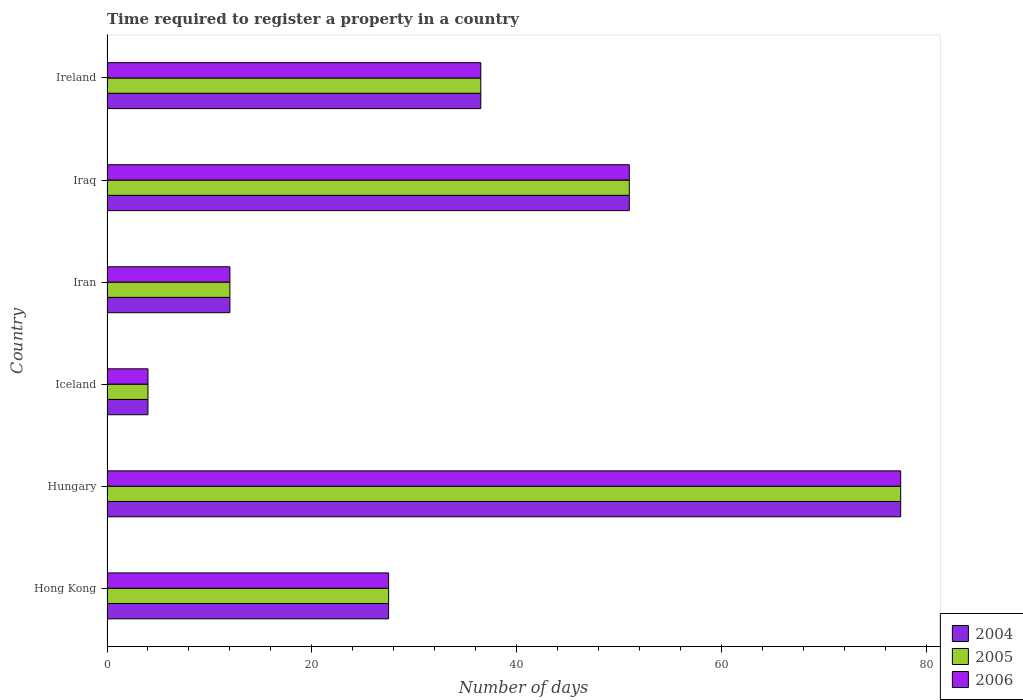How many groups of bars are there?
Offer a very short reply. 6. Are the number of bars on each tick of the Y-axis equal?
Ensure brevity in your answer.  Yes. How many bars are there on the 5th tick from the bottom?
Offer a very short reply. 3. What is the label of the 2nd group of bars from the top?
Offer a very short reply. Iraq. What is the number of days required to register a property in 2006 in Hungary?
Your answer should be very brief. 77.5. Across all countries, what is the maximum number of days required to register a property in 2005?
Provide a succinct answer. 77.5. Across all countries, what is the minimum number of days required to register a property in 2006?
Your answer should be compact. 4. In which country was the number of days required to register a property in 2006 maximum?
Offer a very short reply. Hungary. What is the total number of days required to register a property in 2006 in the graph?
Give a very brief answer. 208.5. What is the difference between the number of days required to register a property in 2004 in Hungary and that in Iran?
Offer a very short reply. 65.5. What is the difference between the number of days required to register a property in 2004 in Iraq and the number of days required to register a property in 2005 in Hong Kong?
Offer a terse response. 23.5. What is the average number of days required to register a property in 2005 per country?
Offer a very short reply. 34.75. What is the difference between the number of days required to register a property in 2004 and number of days required to register a property in 2005 in Hong Kong?
Offer a very short reply. 0. In how many countries, is the number of days required to register a property in 2004 greater than 12 days?
Your answer should be very brief. 4. What is the ratio of the number of days required to register a property in 2006 in Iran to that in Ireland?
Offer a very short reply. 0.33. Is the number of days required to register a property in 2005 in Hungary less than that in Iran?
Your response must be concise. No. Is the difference between the number of days required to register a property in 2004 in Iraq and Ireland greater than the difference between the number of days required to register a property in 2005 in Iraq and Ireland?
Ensure brevity in your answer.  No. What is the difference between the highest and the lowest number of days required to register a property in 2005?
Offer a very short reply. 73.5. Is the sum of the number of days required to register a property in 2004 in Iceland and Iran greater than the maximum number of days required to register a property in 2005 across all countries?
Offer a terse response. No. How many bars are there?
Your response must be concise. 18. Are all the bars in the graph horizontal?
Offer a terse response. Yes. What is the difference between two consecutive major ticks on the X-axis?
Keep it short and to the point. 20. Does the graph contain any zero values?
Offer a very short reply. No. Where does the legend appear in the graph?
Provide a succinct answer. Bottom right. How many legend labels are there?
Your answer should be very brief. 3. What is the title of the graph?
Your response must be concise. Time required to register a property in a country. What is the label or title of the X-axis?
Your answer should be very brief. Number of days. What is the Number of days in 2004 in Hong Kong?
Provide a short and direct response. 27.5. What is the Number of days in 2004 in Hungary?
Keep it short and to the point. 77.5. What is the Number of days in 2005 in Hungary?
Give a very brief answer. 77.5. What is the Number of days of 2006 in Hungary?
Keep it short and to the point. 77.5. What is the Number of days in 2006 in Iceland?
Make the answer very short. 4. What is the Number of days of 2004 in Iran?
Keep it short and to the point. 12. What is the Number of days of 2005 in Iran?
Offer a very short reply. 12. What is the Number of days of 2004 in Iraq?
Give a very brief answer. 51. What is the Number of days of 2005 in Iraq?
Provide a short and direct response. 51. What is the Number of days in 2004 in Ireland?
Make the answer very short. 36.5. What is the Number of days of 2005 in Ireland?
Your answer should be very brief. 36.5. What is the Number of days in 2006 in Ireland?
Offer a terse response. 36.5. Across all countries, what is the maximum Number of days of 2004?
Give a very brief answer. 77.5. Across all countries, what is the maximum Number of days of 2005?
Provide a short and direct response. 77.5. Across all countries, what is the maximum Number of days of 2006?
Offer a terse response. 77.5. Across all countries, what is the minimum Number of days in 2004?
Your answer should be very brief. 4. What is the total Number of days of 2004 in the graph?
Your answer should be very brief. 208.5. What is the total Number of days of 2005 in the graph?
Your answer should be very brief. 208.5. What is the total Number of days in 2006 in the graph?
Your answer should be compact. 208.5. What is the difference between the Number of days in 2006 in Hong Kong and that in Hungary?
Your answer should be very brief. -50. What is the difference between the Number of days in 2004 in Hong Kong and that in Iceland?
Your answer should be compact. 23.5. What is the difference between the Number of days in 2005 in Hong Kong and that in Iceland?
Provide a short and direct response. 23.5. What is the difference between the Number of days in 2006 in Hong Kong and that in Iceland?
Provide a short and direct response. 23.5. What is the difference between the Number of days in 2006 in Hong Kong and that in Iran?
Offer a terse response. 15.5. What is the difference between the Number of days of 2004 in Hong Kong and that in Iraq?
Provide a short and direct response. -23.5. What is the difference between the Number of days in 2005 in Hong Kong and that in Iraq?
Offer a very short reply. -23.5. What is the difference between the Number of days in 2006 in Hong Kong and that in Iraq?
Make the answer very short. -23.5. What is the difference between the Number of days of 2004 in Hong Kong and that in Ireland?
Give a very brief answer. -9. What is the difference between the Number of days of 2005 in Hong Kong and that in Ireland?
Keep it short and to the point. -9. What is the difference between the Number of days in 2004 in Hungary and that in Iceland?
Ensure brevity in your answer.  73.5. What is the difference between the Number of days in 2005 in Hungary and that in Iceland?
Your answer should be very brief. 73.5. What is the difference between the Number of days of 2006 in Hungary and that in Iceland?
Provide a succinct answer. 73.5. What is the difference between the Number of days of 2004 in Hungary and that in Iran?
Your answer should be compact. 65.5. What is the difference between the Number of days in 2005 in Hungary and that in Iran?
Make the answer very short. 65.5. What is the difference between the Number of days of 2006 in Hungary and that in Iran?
Your answer should be very brief. 65.5. What is the difference between the Number of days of 2004 in Hungary and that in Ireland?
Make the answer very short. 41. What is the difference between the Number of days of 2005 in Hungary and that in Ireland?
Offer a terse response. 41. What is the difference between the Number of days in 2004 in Iceland and that in Iran?
Make the answer very short. -8. What is the difference between the Number of days in 2005 in Iceland and that in Iran?
Provide a succinct answer. -8. What is the difference between the Number of days of 2006 in Iceland and that in Iran?
Provide a succinct answer. -8. What is the difference between the Number of days in 2004 in Iceland and that in Iraq?
Provide a short and direct response. -47. What is the difference between the Number of days of 2005 in Iceland and that in Iraq?
Ensure brevity in your answer.  -47. What is the difference between the Number of days of 2006 in Iceland and that in Iraq?
Your answer should be very brief. -47. What is the difference between the Number of days in 2004 in Iceland and that in Ireland?
Ensure brevity in your answer.  -32.5. What is the difference between the Number of days in 2005 in Iceland and that in Ireland?
Provide a short and direct response. -32.5. What is the difference between the Number of days in 2006 in Iceland and that in Ireland?
Make the answer very short. -32.5. What is the difference between the Number of days in 2004 in Iran and that in Iraq?
Offer a terse response. -39. What is the difference between the Number of days in 2005 in Iran and that in Iraq?
Give a very brief answer. -39. What is the difference between the Number of days of 2006 in Iran and that in Iraq?
Make the answer very short. -39. What is the difference between the Number of days of 2004 in Iran and that in Ireland?
Make the answer very short. -24.5. What is the difference between the Number of days of 2005 in Iran and that in Ireland?
Keep it short and to the point. -24.5. What is the difference between the Number of days in 2006 in Iran and that in Ireland?
Give a very brief answer. -24.5. What is the difference between the Number of days of 2006 in Iraq and that in Ireland?
Provide a short and direct response. 14.5. What is the difference between the Number of days of 2004 in Hong Kong and the Number of days of 2005 in Hungary?
Offer a terse response. -50. What is the difference between the Number of days of 2004 in Hong Kong and the Number of days of 2005 in Iceland?
Your response must be concise. 23.5. What is the difference between the Number of days in 2005 in Hong Kong and the Number of days in 2006 in Iceland?
Provide a succinct answer. 23.5. What is the difference between the Number of days in 2004 in Hong Kong and the Number of days in 2005 in Iran?
Offer a very short reply. 15.5. What is the difference between the Number of days of 2004 in Hong Kong and the Number of days of 2005 in Iraq?
Your response must be concise. -23.5. What is the difference between the Number of days in 2004 in Hong Kong and the Number of days in 2006 in Iraq?
Provide a short and direct response. -23.5. What is the difference between the Number of days in 2005 in Hong Kong and the Number of days in 2006 in Iraq?
Your response must be concise. -23.5. What is the difference between the Number of days of 2005 in Hong Kong and the Number of days of 2006 in Ireland?
Provide a short and direct response. -9. What is the difference between the Number of days in 2004 in Hungary and the Number of days in 2005 in Iceland?
Your response must be concise. 73.5. What is the difference between the Number of days in 2004 in Hungary and the Number of days in 2006 in Iceland?
Your answer should be very brief. 73.5. What is the difference between the Number of days of 2005 in Hungary and the Number of days of 2006 in Iceland?
Ensure brevity in your answer.  73.5. What is the difference between the Number of days of 2004 in Hungary and the Number of days of 2005 in Iran?
Give a very brief answer. 65.5. What is the difference between the Number of days of 2004 in Hungary and the Number of days of 2006 in Iran?
Your response must be concise. 65.5. What is the difference between the Number of days in 2005 in Hungary and the Number of days in 2006 in Iran?
Offer a terse response. 65.5. What is the difference between the Number of days of 2004 in Hungary and the Number of days of 2005 in Iraq?
Keep it short and to the point. 26.5. What is the difference between the Number of days of 2005 in Hungary and the Number of days of 2006 in Iraq?
Provide a succinct answer. 26.5. What is the difference between the Number of days of 2005 in Hungary and the Number of days of 2006 in Ireland?
Give a very brief answer. 41. What is the difference between the Number of days of 2004 in Iceland and the Number of days of 2005 in Iran?
Ensure brevity in your answer.  -8. What is the difference between the Number of days in 2005 in Iceland and the Number of days in 2006 in Iran?
Keep it short and to the point. -8. What is the difference between the Number of days of 2004 in Iceland and the Number of days of 2005 in Iraq?
Offer a very short reply. -47. What is the difference between the Number of days in 2004 in Iceland and the Number of days in 2006 in Iraq?
Give a very brief answer. -47. What is the difference between the Number of days in 2005 in Iceland and the Number of days in 2006 in Iraq?
Ensure brevity in your answer.  -47. What is the difference between the Number of days of 2004 in Iceland and the Number of days of 2005 in Ireland?
Provide a succinct answer. -32.5. What is the difference between the Number of days of 2004 in Iceland and the Number of days of 2006 in Ireland?
Make the answer very short. -32.5. What is the difference between the Number of days of 2005 in Iceland and the Number of days of 2006 in Ireland?
Offer a terse response. -32.5. What is the difference between the Number of days of 2004 in Iran and the Number of days of 2005 in Iraq?
Give a very brief answer. -39. What is the difference between the Number of days in 2004 in Iran and the Number of days in 2006 in Iraq?
Provide a succinct answer. -39. What is the difference between the Number of days in 2005 in Iran and the Number of days in 2006 in Iraq?
Provide a short and direct response. -39. What is the difference between the Number of days in 2004 in Iran and the Number of days in 2005 in Ireland?
Your response must be concise. -24.5. What is the difference between the Number of days in 2004 in Iran and the Number of days in 2006 in Ireland?
Your answer should be very brief. -24.5. What is the difference between the Number of days of 2005 in Iran and the Number of days of 2006 in Ireland?
Give a very brief answer. -24.5. What is the difference between the Number of days in 2004 in Iraq and the Number of days in 2006 in Ireland?
Your answer should be compact. 14.5. What is the difference between the Number of days of 2005 in Iraq and the Number of days of 2006 in Ireland?
Your answer should be very brief. 14.5. What is the average Number of days in 2004 per country?
Offer a very short reply. 34.75. What is the average Number of days in 2005 per country?
Provide a short and direct response. 34.75. What is the average Number of days in 2006 per country?
Your response must be concise. 34.75. What is the difference between the Number of days in 2005 and Number of days in 2006 in Hong Kong?
Make the answer very short. 0. What is the difference between the Number of days of 2004 and Number of days of 2005 in Hungary?
Keep it short and to the point. 0. What is the difference between the Number of days of 2004 and Number of days of 2006 in Iceland?
Keep it short and to the point. 0. What is the difference between the Number of days in 2005 and Number of days in 2006 in Iraq?
Give a very brief answer. 0. What is the difference between the Number of days in 2004 and Number of days in 2006 in Ireland?
Your response must be concise. 0. What is the ratio of the Number of days of 2004 in Hong Kong to that in Hungary?
Your answer should be compact. 0.35. What is the ratio of the Number of days in 2005 in Hong Kong to that in Hungary?
Ensure brevity in your answer.  0.35. What is the ratio of the Number of days of 2006 in Hong Kong to that in Hungary?
Your response must be concise. 0.35. What is the ratio of the Number of days of 2004 in Hong Kong to that in Iceland?
Offer a very short reply. 6.88. What is the ratio of the Number of days in 2005 in Hong Kong to that in Iceland?
Offer a terse response. 6.88. What is the ratio of the Number of days of 2006 in Hong Kong to that in Iceland?
Give a very brief answer. 6.88. What is the ratio of the Number of days of 2004 in Hong Kong to that in Iran?
Your answer should be very brief. 2.29. What is the ratio of the Number of days in 2005 in Hong Kong to that in Iran?
Your answer should be very brief. 2.29. What is the ratio of the Number of days of 2006 in Hong Kong to that in Iran?
Make the answer very short. 2.29. What is the ratio of the Number of days of 2004 in Hong Kong to that in Iraq?
Offer a terse response. 0.54. What is the ratio of the Number of days in 2005 in Hong Kong to that in Iraq?
Provide a short and direct response. 0.54. What is the ratio of the Number of days of 2006 in Hong Kong to that in Iraq?
Offer a very short reply. 0.54. What is the ratio of the Number of days of 2004 in Hong Kong to that in Ireland?
Offer a terse response. 0.75. What is the ratio of the Number of days of 2005 in Hong Kong to that in Ireland?
Keep it short and to the point. 0.75. What is the ratio of the Number of days of 2006 in Hong Kong to that in Ireland?
Offer a very short reply. 0.75. What is the ratio of the Number of days of 2004 in Hungary to that in Iceland?
Your response must be concise. 19.38. What is the ratio of the Number of days of 2005 in Hungary to that in Iceland?
Your answer should be compact. 19.38. What is the ratio of the Number of days in 2006 in Hungary to that in Iceland?
Offer a terse response. 19.38. What is the ratio of the Number of days of 2004 in Hungary to that in Iran?
Provide a short and direct response. 6.46. What is the ratio of the Number of days in 2005 in Hungary to that in Iran?
Keep it short and to the point. 6.46. What is the ratio of the Number of days of 2006 in Hungary to that in Iran?
Your answer should be very brief. 6.46. What is the ratio of the Number of days in 2004 in Hungary to that in Iraq?
Your answer should be compact. 1.52. What is the ratio of the Number of days of 2005 in Hungary to that in Iraq?
Keep it short and to the point. 1.52. What is the ratio of the Number of days in 2006 in Hungary to that in Iraq?
Make the answer very short. 1.52. What is the ratio of the Number of days in 2004 in Hungary to that in Ireland?
Your response must be concise. 2.12. What is the ratio of the Number of days in 2005 in Hungary to that in Ireland?
Give a very brief answer. 2.12. What is the ratio of the Number of days in 2006 in Hungary to that in Ireland?
Make the answer very short. 2.12. What is the ratio of the Number of days in 2005 in Iceland to that in Iran?
Ensure brevity in your answer.  0.33. What is the ratio of the Number of days in 2006 in Iceland to that in Iran?
Ensure brevity in your answer.  0.33. What is the ratio of the Number of days in 2004 in Iceland to that in Iraq?
Your answer should be very brief. 0.08. What is the ratio of the Number of days of 2005 in Iceland to that in Iraq?
Give a very brief answer. 0.08. What is the ratio of the Number of days in 2006 in Iceland to that in Iraq?
Ensure brevity in your answer.  0.08. What is the ratio of the Number of days of 2004 in Iceland to that in Ireland?
Provide a short and direct response. 0.11. What is the ratio of the Number of days of 2005 in Iceland to that in Ireland?
Give a very brief answer. 0.11. What is the ratio of the Number of days in 2006 in Iceland to that in Ireland?
Your response must be concise. 0.11. What is the ratio of the Number of days in 2004 in Iran to that in Iraq?
Your answer should be very brief. 0.24. What is the ratio of the Number of days in 2005 in Iran to that in Iraq?
Your answer should be compact. 0.24. What is the ratio of the Number of days in 2006 in Iran to that in Iraq?
Offer a terse response. 0.24. What is the ratio of the Number of days of 2004 in Iran to that in Ireland?
Your response must be concise. 0.33. What is the ratio of the Number of days of 2005 in Iran to that in Ireland?
Make the answer very short. 0.33. What is the ratio of the Number of days of 2006 in Iran to that in Ireland?
Your answer should be compact. 0.33. What is the ratio of the Number of days of 2004 in Iraq to that in Ireland?
Give a very brief answer. 1.4. What is the ratio of the Number of days of 2005 in Iraq to that in Ireland?
Your response must be concise. 1.4. What is the ratio of the Number of days of 2006 in Iraq to that in Ireland?
Offer a terse response. 1.4. What is the difference between the highest and the second highest Number of days in 2006?
Your response must be concise. 26.5. What is the difference between the highest and the lowest Number of days in 2004?
Offer a terse response. 73.5. What is the difference between the highest and the lowest Number of days in 2005?
Your answer should be compact. 73.5. What is the difference between the highest and the lowest Number of days in 2006?
Give a very brief answer. 73.5. 